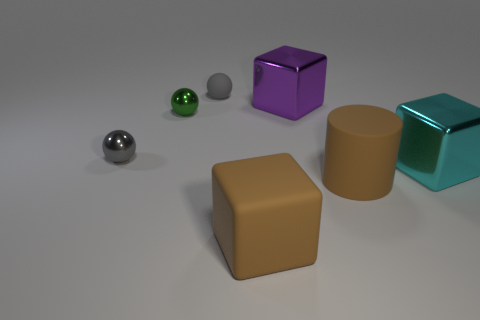Add 1 metallic cubes. How many objects exist? 8 Subtract all balls. How many objects are left? 4 Subtract all small red cubes. Subtract all metal things. How many objects are left? 3 Add 1 metal balls. How many metal balls are left? 3 Add 1 big brown objects. How many big brown objects exist? 3 Subtract 1 green balls. How many objects are left? 6 